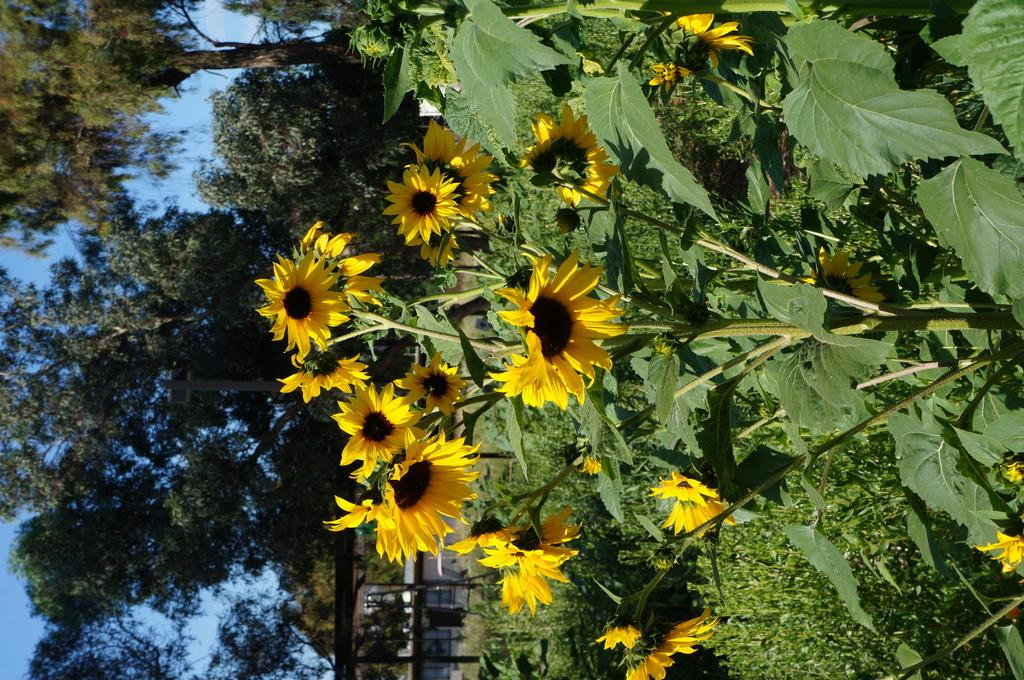What type of plants are featured in the image? There are sunflowers in the image. Are there any other plants visible besides the sunflowers? Yes, there are other plants in the image. What can be seen in the background of the image? There are trees and the sky visible in the background of the image. What type of beef is being prepared by the grandmother in the image? There is no grandmother or beef present in the image. Who is the creator of the sunflowers in the image? The image does not provide information about the creator of the sunflowers; it simply shows the sunflowers themselves. 